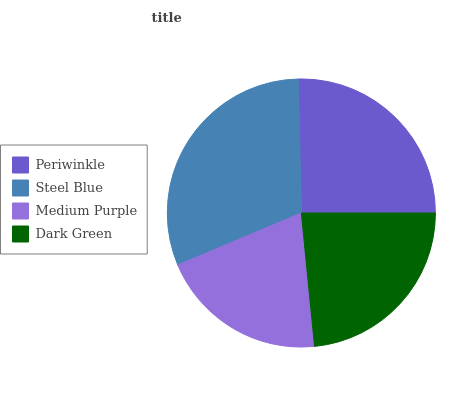Is Medium Purple the minimum?
Answer yes or no. Yes. Is Steel Blue the maximum?
Answer yes or no. Yes. Is Steel Blue the minimum?
Answer yes or no. No. Is Medium Purple the maximum?
Answer yes or no. No. Is Steel Blue greater than Medium Purple?
Answer yes or no. Yes. Is Medium Purple less than Steel Blue?
Answer yes or no. Yes. Is Medium Purple greater than Steel Blue?
Answer yes or no. No. Is Steel Blue less than Medium Purple?
Answer yes or no. No. Is Periwinkle the high median?
Answer yes or no. Yes. Is Dark Green the low median?
Answer yes or no. Yes. Is Steel Blue the high median?
Answer yes or no. No. Is Steel Blue the low median?
Answer yes or no. No. 